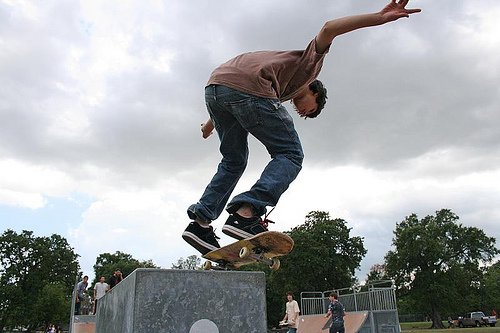<image>
Can you confirm if the trucks is under the board? Yes. The trucks is positioned underneath the board, with the board above it in the vertical space. 